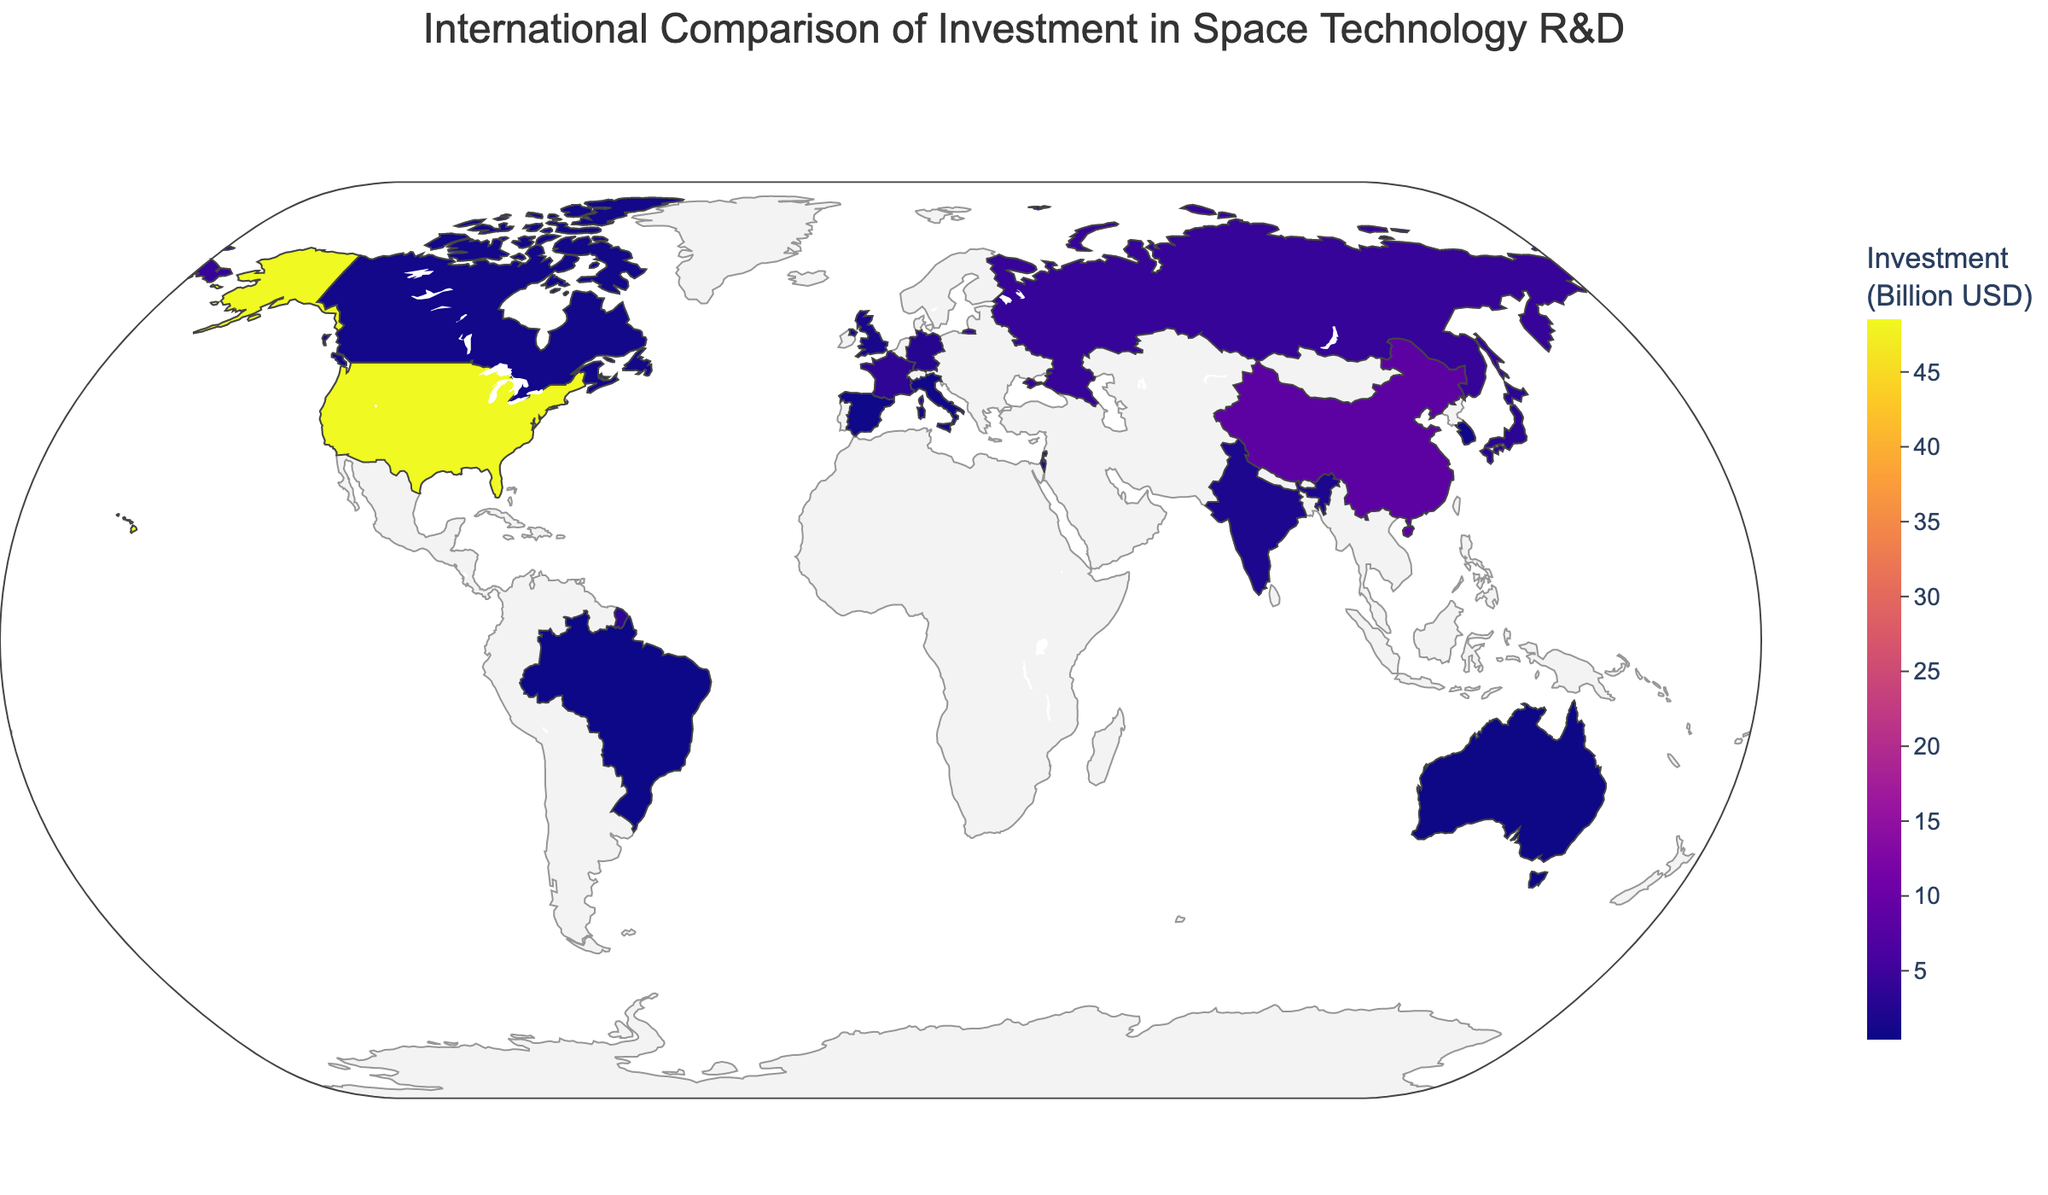What is the country with the highest investment in space technology R&D? By visually examining the plot, the United States is marked with the highest color intensity, indicating the highest investment value.
Answer: United States What is the total investment of the top three countries combined? The top three countries by visual inspection of the color intensity are the United States, China, and Russia. Summing their values: 48.5 (United States) + 8.4 (China) + 4.2 (Russia) = 61.1 billion USD.
Answer: 61.1 billion USD Which country has a higher investment - Japan or Germany? By comparing the color intensities and hovering over the countries, Japan has an investment of 3.2 billion USD while Germany has 2.7 billion USD. Thus, Japan has a higher investment.
Answer: Japan What is the median investment among all listed countries? Listing the countries' investments in ascending order: 0.4, 0.5, 0.6, 0.7, 0.8, 0.9, 1.2, 1.5, 1.9, 2.7, 3.2, 3.6, 4.2, 8.4, 48.5. The median value is the middle number, which is the 8th value (1.5) as there are 15 countries.
Answer: 1.5 billion USD How much more does Israel invest in R&D compared to Canada? By inspecting the plot and values, Israel invests 1.2 billion USD while Canada invests 0.9 billion USD. The difference is 1.2 - 0.9 = 0.3 billion USD.
Answer: 0.3 billion USD Which color scale is used to represent the investment values? By examining the plot and hover information, the color scale used is 'Plasma'.
Answer: Plasma How many countries have investments greater than or equal to 3 billion USD? Countries with investments greater than or equal to 3 billion USD are the United States, China, Russia, France, and Japan. Counting these, we have 5 countries.
Answer: 5 countries What is the range of investment values depicted in the plot? The lowest investment value is 0.4 billion USD (Brazil), and the highest is 48.5 billion USD (United States). Therefore, the range is 48.5 - 0.4 = 48.1 billion USD.
Answer: 48.1 billion USD Which country has the closest investment to the average investment among all listed countries? To find the average: (48.5 + 8.4 + 4.2 + 3.6 + 3.2 + 2.7 + 1.9 + 1.5 + 1.2 + 0.9 + 0.8 + 0.7 + 0.6 + 0.5 + 0.4) / 15 = 5.3733 billion USD approximately. From the countries' investments, China (8.4 billion USD) is closest to this average.
Answer: China 